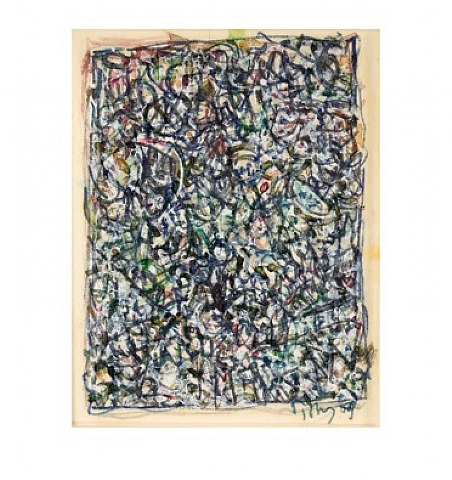How might someone new to abstract art begin to interpret this piece? For someone new to abstract art, interpreting a piece like this can seem daunting at first. A good starting point is to approach the artwork with an open mind and take in the overall impression it creates. Notice the colors—how do they make you feel? Do the lines and shapes evoke any particular emotions or thoughts?

Instead of trying to find a specific, concrete meaning, consider what the painting's elements remind you of. Do the intertwined lines suggest movement, chaos, or perhaps harmony? Are there any particular sections that stand out to you?

Remember, abstract art is often more about evoking a feeling or reaction rather than depicting something recognizable. Trust your instincts and personal responses to the piece. With time and exposure to more abstract works, you'll develop your own way of interpreting and appreciating this unique art form. Can you create a poetic description of what you see in the painting? Upon the canvas, chaos dances free,
A tangled web of hues, a wild spree,
Blue whispers with green, a secret in flight,
Red’s bold embrace, a flash of light.

A symphony of lines, a tangled song,
In Pollock’s maze, where colors belong,
Each splatter sings of dreams untamed,
Where art and emotion are unframed.

Motion captured in static delight,
A midnight sky in daylight’s sight,
Each stroke a heartbeat, pulsing, free,
In this painted world, we cease to be. 